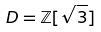Convert formula to latex. <formula><loc_0><loc_0><loc_500><loc_500>D = \mathbb { Z } [ \sqrt { 3 } ]</formula> 